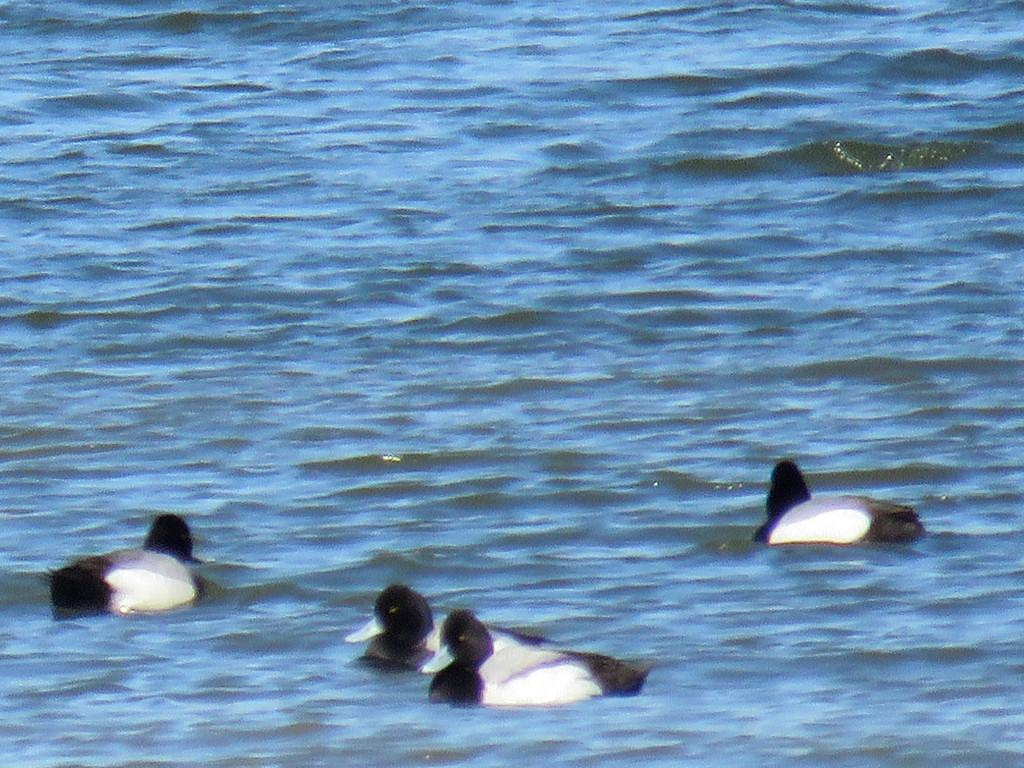What type of animals can be seen in the foreground of the image? There are birds in the foreground of the image. What is visible at the bottom of the image? There is water visible at the bottom of the image. What type of blade can be seen cutting through the mist in the image? There is no blade or mist present in the image; it features birds in the foreground and water at the bottom. 